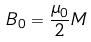Convert formula to latex. <formula><loc_0><loc_0><loc_500><loc_500>B _ { 0 } = \frac { \mu _ { 0 } } { 2 } M</formula> 